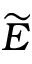<formula> <loc_0><loc_0><loc_500><loc_500>\widetilde { E }</formula> 